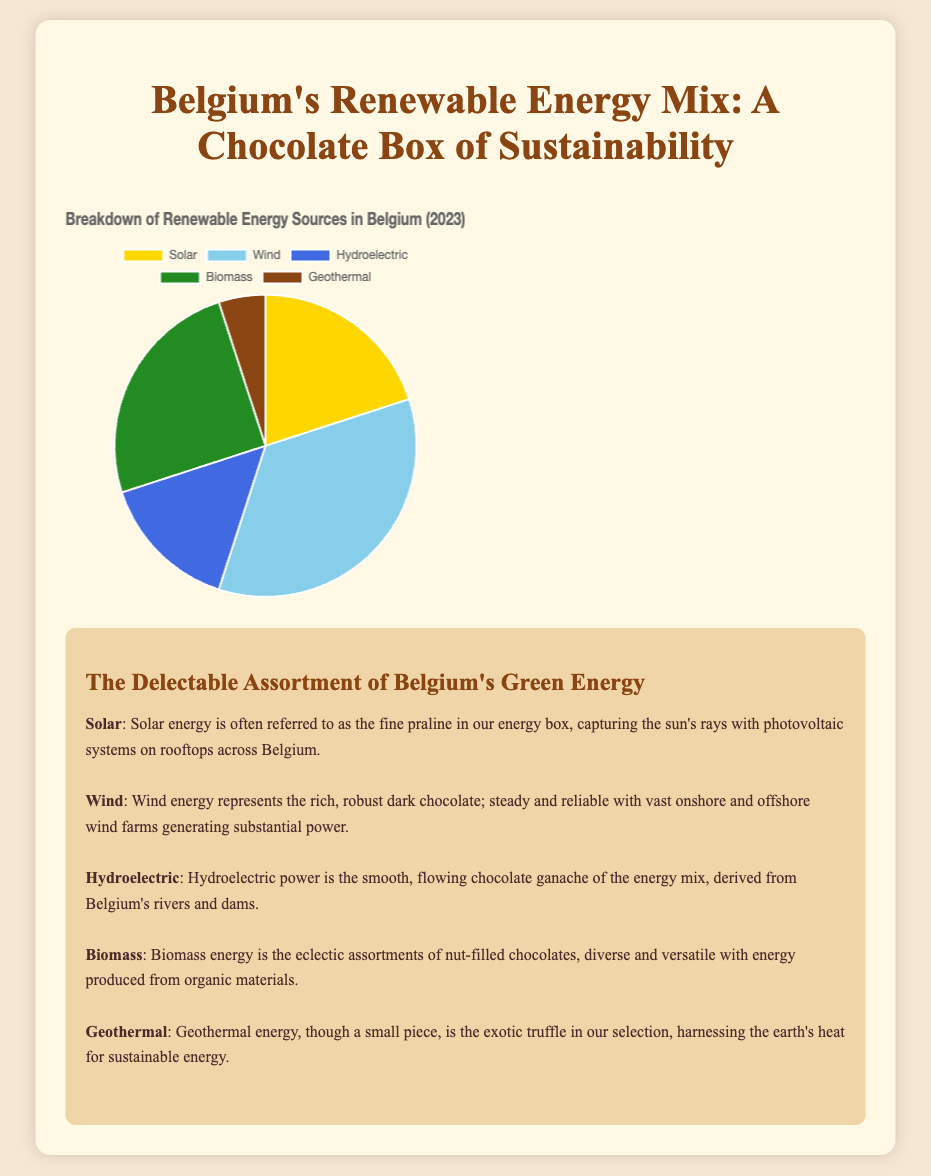What percentage of renewable energy sources does wind energy contribute in Belgium? Wind energy contributes 35% to the renewable energy sources in Belgium as seen from the pie chart segment labeled "Wind."
Answer: 35% Which renewable energy source has the smallest contribution in Belgium? The pie chart segment representing Geothermal energy occupies the smallest area, indicating it has the smallest contribution at 5%.
Answer: Geothermal What is the combined percentage of Solar and Biomass energy sources? Solar and Biomass contributions can be added together, Solar being 20% and Biomass being 25%. So, 20% + 25% = 45%.
Answer: 45% Is the contribution of Hydroelectric energy greater or smaller than Biomass energy? Hydroelectric energy contributes 15%, whereas Biomass energy contributes 25%. Since 15% is less than 25%, Hydroelectric energy's contribution is smaller than Biomass energy's.
Answer: Smaller What is the visual color used to represent Solar energy on the pie chart? The pie chart uses a segment with a yellow-like color to represent Solar energy.
Answer: Yellow-like Which renewable energy source contributes more: Solar or Hydroelectric? The chart shows that Solar contributes 20%, while Hydroelectric contributes 15%. Since 20% is greater than 15%, Solar energy's contribution is more.
Answer: Solar What is the difference in percentage points between the highest and lowest contributing energy sources? The highest contributor is Wind at 35%, and the lowest is Geothermal at 5%. The difference is 35% - 5% = 30%.
Answer: 30% What is the average contribution of Wind, Biomass, and Geothermal energy sources? To find the average, sum the contributions: 35% (Wind) + 25% (Biomass) + 5% (Geothermal) = 65%, and then divide by 3 (number of sources): 65% / 3 ≈ 21.67%.
Answer: 21.67% Which two energy sources, when combined, contribute the majority of the total percentage? Adding the percentages: Wind (35%) and Biomass (25%) gives 35% + 25% = 60%, which is more than half of the total (majority).
Answer: Wind and Biomass 